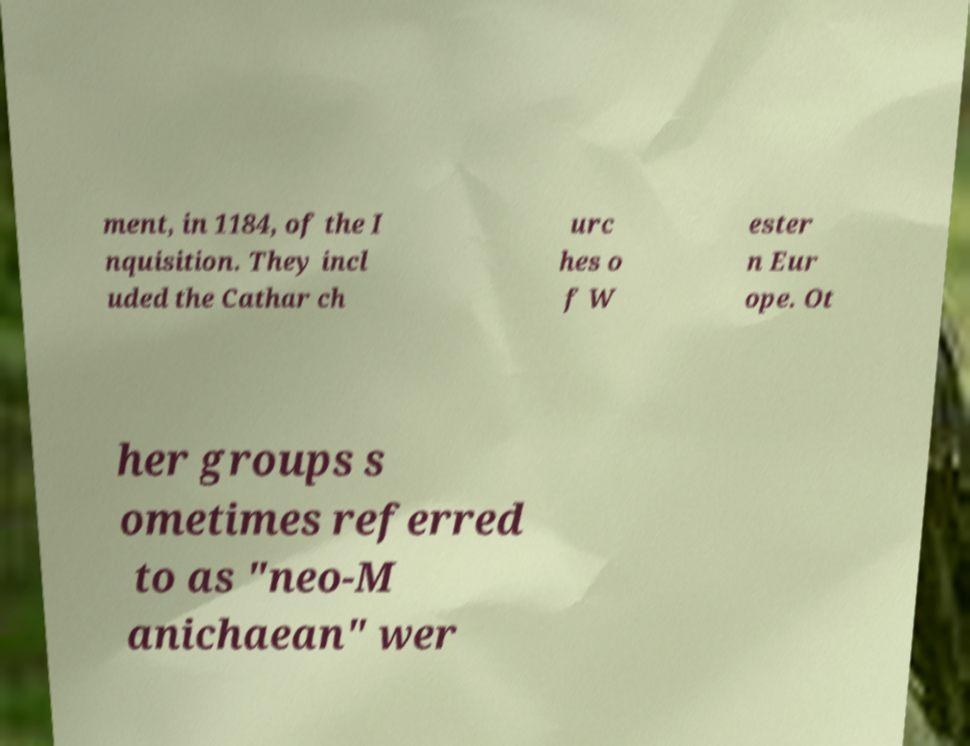Could you extract and type out the text from this image? ment, in 1184, of the I nquisition. They incl uded the Cathar ch urc hes o f W ester n Eur ope. Ot her groups s ometimes referred to as "neo-M anichaean" wer 